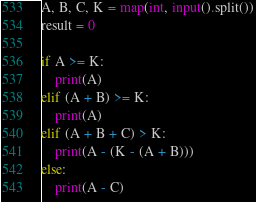<code> <loc_0><loc_0><loc_500><loc_500><_Python_>A, B, C, K = map(int, input().split())
result = 0

if A >= K:
    print(A)
elif (A + B) >= K:
    print(A)
elif (A + B + C) > K:
    print(A - (K - (A + B)))
else:
    print(A - C)</code> 